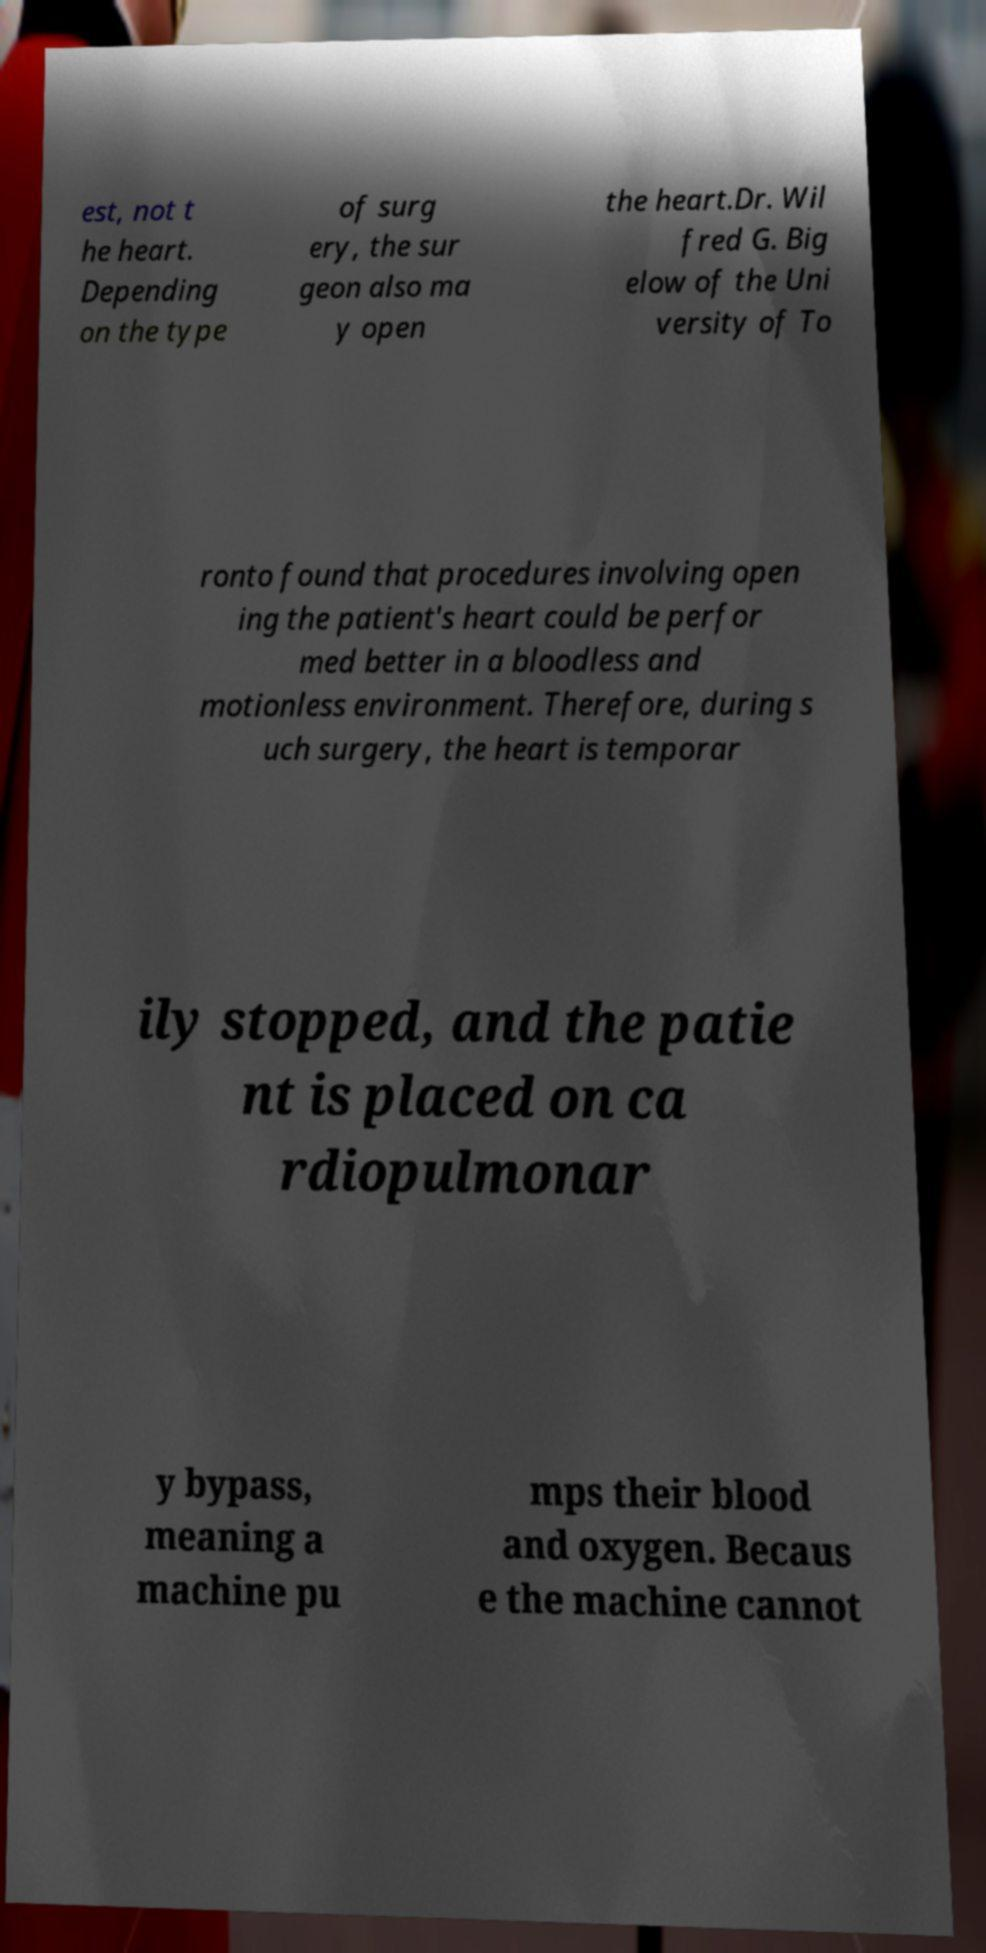I need the written content from this picture converted into text. Can you do that? est, not t he heart. Depending on the type of surg ery, the sur geon also ma y open the heart.Dr. Wil fred G. Big elow of the Uni versity of To ronto found that procedures involving open ing the patient's heart could be perfor med better in a bloodless and motionless environment. Therefore, during s uch surgery, the heart is temporar ily stopped, and the patie nt is placed on ca rdiopulmonar y bypass, meaning a machine pu mps their blood and oxygen. Becaus e the machine cannot 